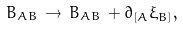Convert formula to latex. <formula><loc_0><loc_0><loc_500><loc_500>B _ { A B } \, \rightarrow \, B _ { A B } \, + \partial _ { [ A } \xi _ { B ] } ,</formula> 